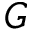<formula> <loc_0><loc_0><loc_500><loc_500>G</formula> 